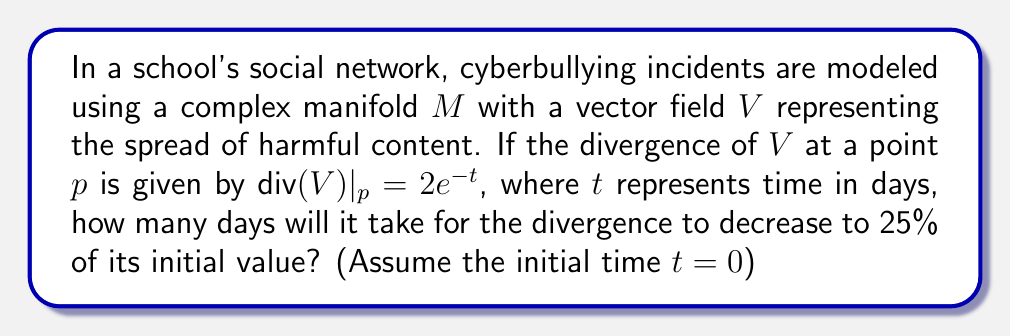Can you solve this math problem? To solve this problem, we need to understand the concept of divergence in vector fields and how it relates to the spread of cyberbullying in this model. The divergence represents the rate at which the harmful content is spreading or concentrating at a given point.

Given:
- The divergence of $V$ at point $p$ is $\text{div}(V)|_p = 2e^{-t}$
- $t$ represents time in days
- We want to find when the divergence decreases to 25% of its initial value

Step 1: Determine the initial value of the divergence (at $t=0$).
$$\text{div}(V)|_{p,t=0} = 2e^{-0} = 2$$

Step 2: Calculate 25% of the initial value.
$$25\% \text{ of initial value} = 0.25 \times 2 = 0.5$$

Step 3: Set up an equation to solve for $t$ when the divergence equals 0.5.
$$2e^{-t} = 0.5$$

Step 4: Solve the equation for $t$.
$$e^{-t} = 0.25$$
$$-t = \ln(0.25)$$
$$t = -\ln(0.25) = \ln(4) \approx 1.3863$$

Therefore, it will take approximately 1.3863 days for the divergence to decrease to 25% of its initial value.
Answer: $t = \ln(4) \approx 1.3863$ days 